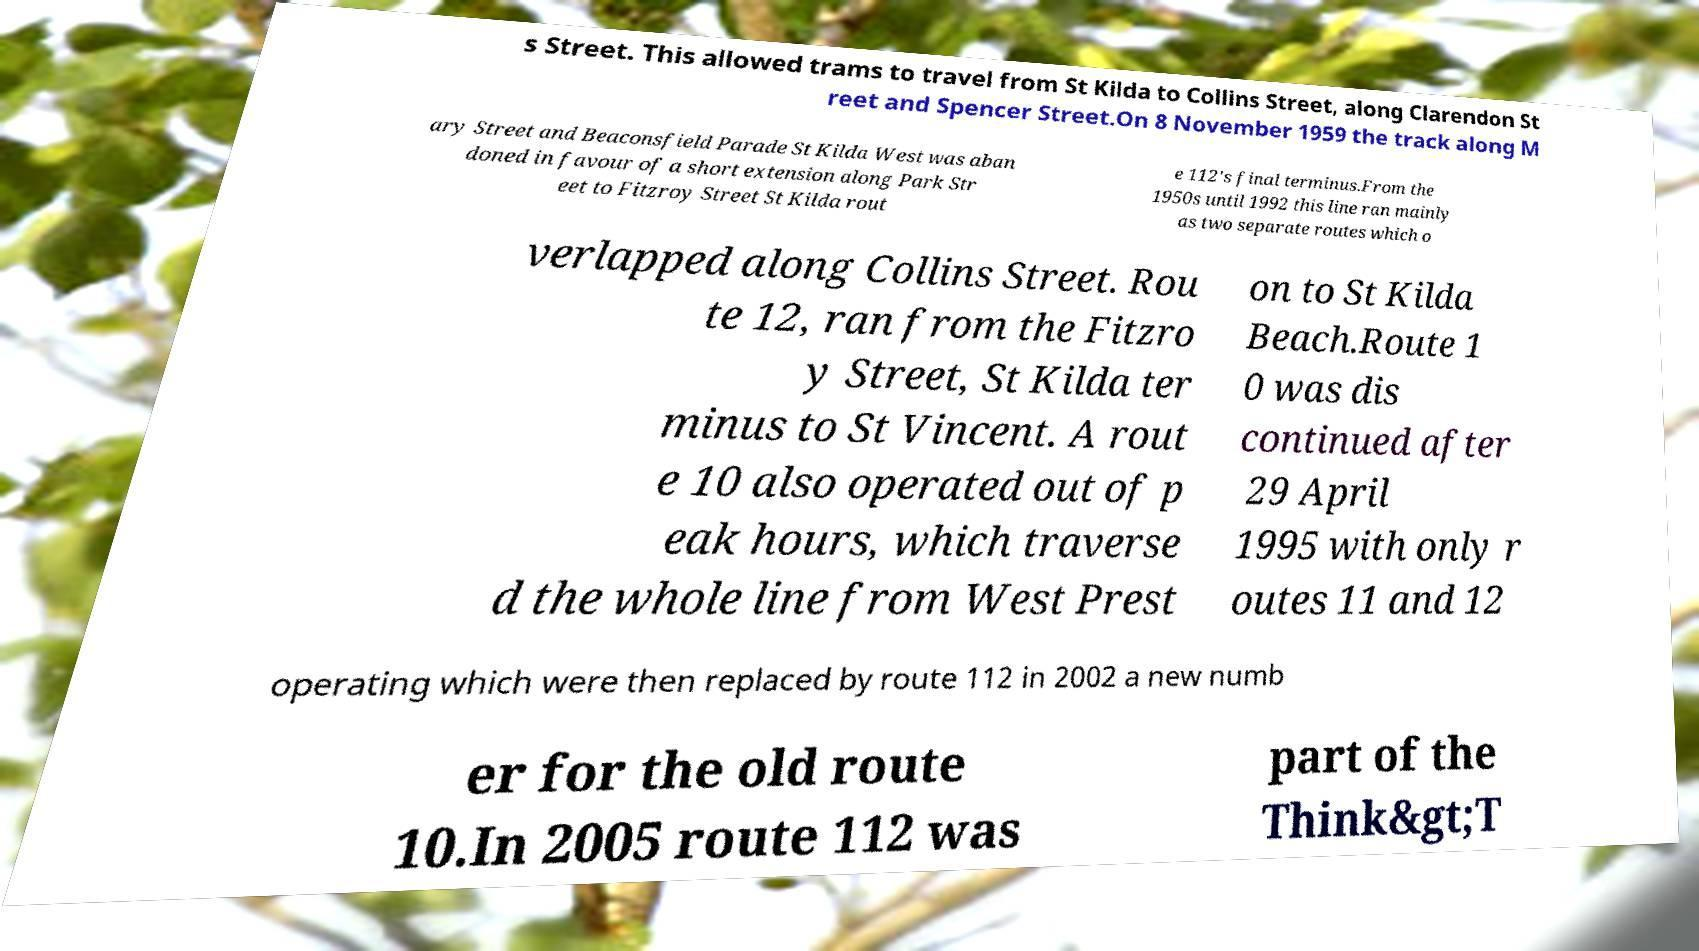For documentation purposes, I need the text within this image transcribed. Could you provide that? s Street. This allowed trams to travel from St Kilda to Collins Street, along Clarendon St reet and Spencer Street.On 8 November 1959 the track along M ary Street and Beaconsfield Parade St Kilda West was aban doned in favour of a short extension along Park Str eet to Fitzroy Street St Kilda rout e 112's final terminus.From the 1950s until 1992 this line ran mainly as two separate routes which o verlapped along Collins Street. Rou te 12, ran from the Fitzro y Street, St Kilda ter minus to St Vincent. A rout e 10 also operated out of p eak hours, which traverse d the whole line from West Prest on to St Kilda Beach.Route 1 0 was dis continued after 29 April 1995 with only r outes 11 and 12 operating which were then replaced by route 112 in 2002 a new numb er for the old route 10.In 2005 route 112 was part of the Think&gt;T 